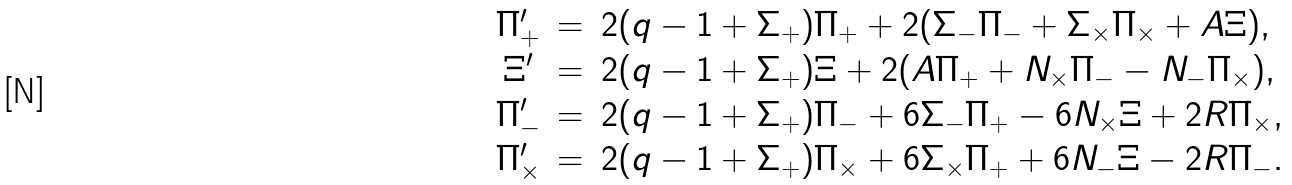Convert formula to latex. <formula><loc_0><loc_0><loc_500><loc_500>\begin{array} { c c l } \Pi _ { + } ^ { \prime } & = & 2 ( q - 1 + \Sigma _ { + } ) \Pi _ { + } + 2 ( \Sigma _ { - } \Pi _ { - } + \Sigma _ { \times } \Pi _ { \times } + A \Xi ) , \\ \Xi ^ { \prime } & = & 2 ( q - 1 + \Sigma _ { + } ) \Xi + 2 ( A \Pi _ { + } + N _ { \times } \Pi _ { - } - N _ { - } \Pi _ { \times } ) , \\ \Pi _ { - } ^ { \prime } & = & 2 ( q - 1 + \Sigma _ { + } ) \Pi _ { - } + 6 \Sigma _ { - } \Pi _ { + } - 6 N _ { \times } \Xi + 2 R \Pi _ { \times } , \\ \Pi _ { \times } ^ { \prime } & = & 2 ( q - 1 + \Sigma _ { + } ) \Pi _ { \times } + 6 \Sigma _ { \times } \Pi _ { + } + 6 N _ { - } \Xi - 2 R \Pi _ { - } . \end{array}</formula> 